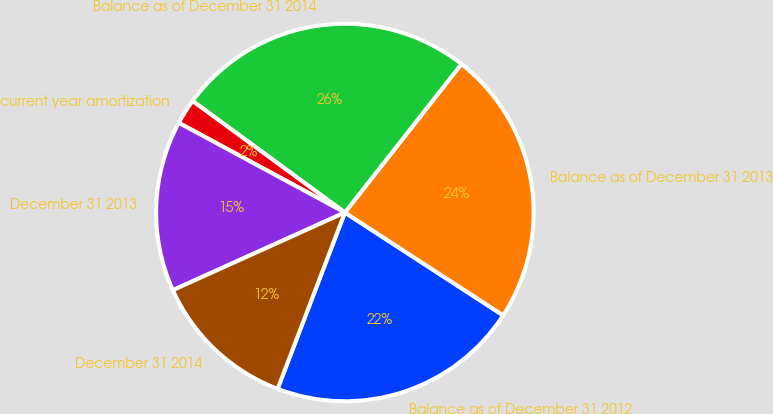Convert chart. <chart><loc_0><loc_0><loc_500><loc_500><pie_chart><fcel>Balance as of December 31 2012<fcel>Balance as of December 31 2013<fcel>Balance as of December 31 2014<fcel>current year amortization<fcel>December 31 2013<fcel>December 31 2014<nl><fcel>21.63%<fcel>23.58%<fcel>25.53%<fcel>2.18%<fcel>14.63%<fcel>12.45%<nl></chart> 